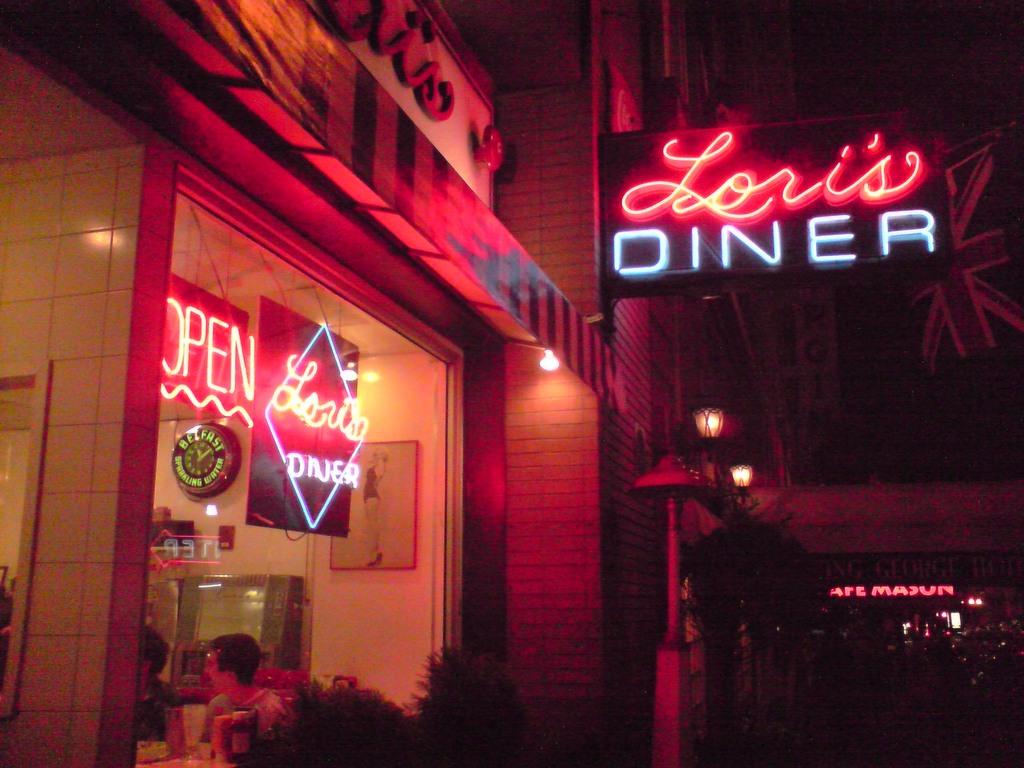Whose diner is this?
Offer a very short reply. Lori's. Is the diner open or closed?
Provide a short and direct response. Open. 